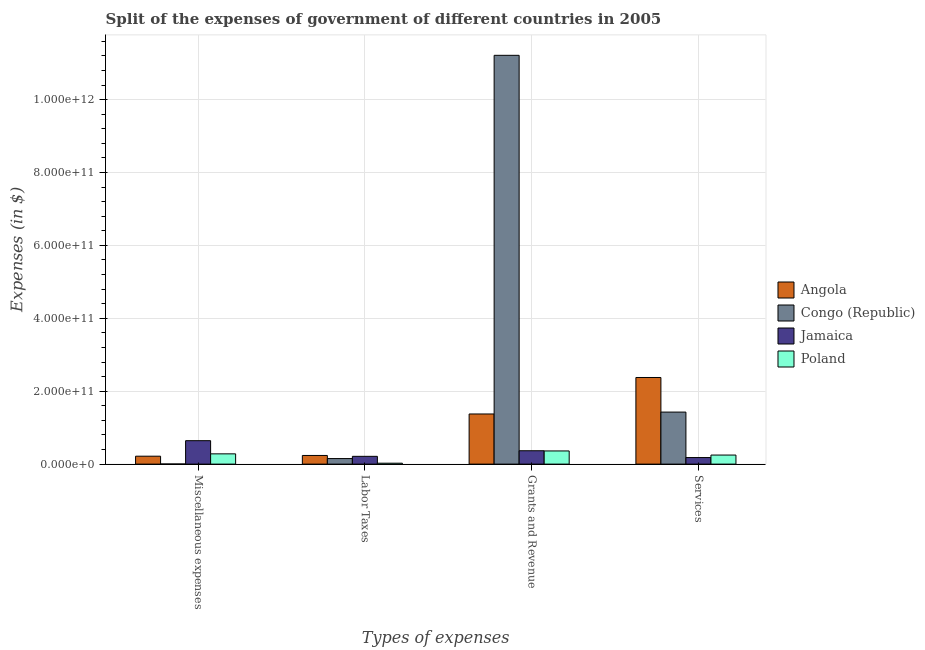Are the number of bars on each tick of the X-axis equal?
Give a very brief answer. Yes. How many bars are there on the 2nd tick from the left?
Your response must be concise. 4. What is the label of the 3rd group of bars from the left?
Provide a succinct answer. Grants and Revenue. What is the amount spent on miscellaneous expenses in Jamaica?
Offer a terse response. 6.43e+1. Across all countries, what is the maximum amount spent on services?
Provide a succinct answer. 2.38e+11. Across all countries, what is the minimum amount spent on grants and revenue?
Give a very brief answer. 3.61e+1. In which country was the amount spent on grants and revenue maximum?
Offer a terse response. Congo (Republic). In which country was the amount spent on miscellaneous expenses minimum?
Your answer should be compact. Congo (Republic). What is the total amount spent on services in the graph?
Make the answer very short. 4.23e+11. What is the difference between the amount spent on grants and revenue in Angola and that in Poland?
Make the answer very short. 1.01e+11. What is the difference between the amount spent on labor taxes in Angola and the amount spent on grants and revenue in Congo (Republic)?
Keep it short and to the point. -1.10e+12. What is the average amount spent on services per country?
Make the answer very short. 1.06e+11. What is the difference between the amount spent on labor taxes and amount spent on grants and revenue in Jamaica?
Provide a short and direct response. -1.53e+1. What is the ratio of the amount spent on services in Jamaica to that in Poland?
Offer a terse response. 0.72. Is the difference between the amount spent on services in Poland and Congo (Republic) greater than the difference between the amount spent on miscellaneous expenses in Poland and Congo (Republic)?
Keep it short and to the point. No. What is the difference between the highest and the second highest amount spent on services?
Provide a succinct answer. 9.49e+1. What is the difference between the highest and the lowest amount spent on labor taxes?
Your answer should be compact. 2.12e+1. Are all the bars in the graph horizontal?
Your response must be concise. No. What is the difference between two consecutive major ticks on the Y-axis?
Offer a very short reply. 2.00e+11. Does the graph contain any zero values?
Keep it short and to the point. No. Does the graph contain grids?
Give a very brief answer. Yes. How many legend labels are there?
Give a very brief answer. 4. What is the title of the graph?
Keep it short and to the point. Split of the expenses of government of different countries in 2005. Does "Cambodia" appear as one of the legend labels in the graph?
Provide a short and direct response. No. What is the label or title of the X-axis?
Give a very brief answer. Types of expenses. What is the label or title of the Y-axis?
Provide a short and direct response. Expenses (in $). What is the Expenses (in $) in Angola in Miscellaneous expenses?
Provide a short and direct response. 2.17e+1. What is the Expenses (in $) of Congo (Republic) in Miscellaneous expenses?
Your answer should be very brief. 3.32e+08. What is the Expenses (in $) in Jamaica in Miscellaneous expenses?
Your response must be concise. 6.43e+1. What is the Expenses (in $) of Poland in Miscellaneous expenses?
Ensure brevity in your answer.  2.82e+1. What is the Expenses (in $) of Angola in Labor Taxes?
Provide a succinct answer. 2.37e+1. What is the Expenses (in $) of Congo (Republic) in Labor Taxes?
Offer a very short reply. 1.52e+1. What is the Expenses (in $) in Jamaica in Labor Taxes?
Offer a terse response. 2.14e+1. What is the Expenses (in $) in Poland in Labor Taxes?
Make the answer very short. 2.50e+09. What is the Expenses (in $) of Angola in Grants and Revenue?
Your answer should be very brief. 1.38e+11. What is the Expenses (in $) in Congo (Republic) in Grants and Revenue?
Provide a succinct answer. 1.12e+12. What is the Expenses (in $) in Jamaica in Grants and Revenue?
Your answer should be compact. 3.67e+1. What is the Expenses (in $) of Poland in Grants and Revenue?
Your response must be concise. 3.61e+1. What is the Expenses (in $) in Angola in Services?
Ensure brevity in your answer.  2.38e+11. What is the Expenses (in $) of Congo (Republic) in Services?
Ensure brevity in your answer.  1.43e+11. What is the Expenses (in $) of Jamaica in Services?
Your response must be concise. 1.80e+1. What is the Expenses (in $) of Poland in Services?
Your answer should be compact. 2.49e+1. Across all Types of expenses, what is the maximum Expenses (in $) in Angola?
Your answer should be very brief. 2.38e+11. Across all Types of expenses, what is the maximum Expenses (in $) in Congo (Republic)?
Give a very brief answer. 1.12e+12. Across all Types of expenses, what is the maximum Expenses (in $) in Jamaica?
Keep it short and to the point. 6.43e+1. Across all Types of expenses, what is the maximum Expenses (in $) of Poland?
Make the answer very short. 3.61e+1. Across all Types of expenses, what is the minimum Expenses (in $) of Angola?
Keep it short and to the point. 2.17e+1. Across all Types of expenses, what is the minimum Expenses (in $) of Congo (Republic)?
Provide a short and direct response. 3.32e+08. Across all Types of expenses, what is the minimum Expenses (in $) of Jamaica?
Make the answer very short. 1.80e+1. Across all Types of expenses, what is the minimum Expenses (in $) of Poland?
Give a very brief answer. 2.50e+09. What is the total Expenses (in $) of Angola in the graph?
Provide a short and direct response. 4.21e+11. What is the total Expenses (in $) in Congo (Republic) in the graph?
Offer a terse response. 1.28e+12. What is the total Expenses (in $) in Jamaica in the graph?
Make the answer very short. 1.40e+11. What is the total Expenses (in $) in Poland in the graph?
Make the answer very short. 9.17e+1. What is the difference between the Expenses (in $) in Angola in Miscellaneous expenses and that in Labor Taxes?
Your answer should be very brief. -1.98e+09. What is the difference between the Expenses (in $) in Congo (Republic) in Miscellaneous expenses and that in Labor Taxes?
Ensure brevity in your answer.  -1.49e+1. What is the difference between the Expenses (in $) of Jamaica in Miscellaneous expenses and that in Labor Taxes?
Ensure brevity in your answer.  4.30e+1. What is the difference between the Expenses (in $) in Poland in Miscellaneous expenses and that in Labor Taxes?
Offer a terse response. 2.57e+1. What is the difference between the Expenses (in $) in Angola in Miscellaneous expenses and that in Grants and Revenue?
Your answer should be very brief. -1.16e+11. What is the difference between the Expenses (in $) of Congo (Republic) in Miscellaneous expenses and that in Grants and Revenue?
Offer a very short reply. -1.12e+12. What is the difference between the Expenses (in $) of Jamaica in Miscellaneous expenses and that in Grants and Revenue?
Offer a terse response. 2.76e+1. What is the difference between the Expenses (in $) of Poland in Miscellaneous expenses and that in Grants and Revenue?
Your answer should be very brief. -7.94e+09. What is the difference between the Expenses (in $) of Angola in Miscellaneous expenses and that in Services?
Provide a short and direct response. -2.16e+11. What is the difference between the Expenses (in $) of Congo (Republic) in Miscellaneous expenses and that in Services?
Offer a very short reply. -1.42e+11. What is the difference between the Expenses (in $) in Jamaica in Miscellaneous expenses and that in Services?
Provide a short and direct response. 4.63e+1. What is the difference between the Expenses (in $) in Poland in Miscellaneous expenses and that in Services?
Ensure brevity in your answer.  3.32e+09. What is the difference between the Expenses (in $) in Angola in Labor Taxes and that in Grants and Revenue?
Offer a terse response. -1.14e+11. What is the difference between the Expenses (in $) in Congo (Republic) in Labor Taxes and that in Grants and Revenue?
Your answer should be compact. -1.11e+12. What is the difference between the Expenses (in $) of Jamaica in Labor Taxes and that in Grants and Revenue?
Ensure brevity in your answer.  -1.53e+1. What is the difference between the Expenses (in $) in Poland in Labor Taxes and that in Grants and Revenue?
Keep it short and to the point. -3.36e+1. What is the difference between the Expenses (in $) in Angola in Labor Taxes and that in Services?
Ensure brevity in your answer.  -2.14e+11. What is the difference between the Expenses (in $) of Congo (Republic) in Labor Taxes and that in Services?
Ensure brevity in your answer.  -1.28e+11. What is the difference between the Expenses (in $) in Jamaica in Labor Taxes and that in Services?
Keep it short and to the point. 3.35e+09. What is the difference between the Expenses (in $) in Poland in Labor Taxes and that in Services?
Your response must be concise. -2.24e+1. What is the difference between the Expenses (in $) in Angola in Grants and Revenue and that in Services?
Your answer should be compact. -1.00e+11. What is the difference between the Expenses (in $) in Congo (Republic) in Grants and Revenue and that in Services?
Keep it short and to the point. 9.79e+11. What is the difference between the Expenses (in $) of Jamaica in Grants and Revenue and that in Services?
Your answer should be compact. 1.87e+1. What is the difference between the Expenses (in $) in Poland in Grants and Revenue and that in Services?
Make the answer very short. 1.13e+1. What is the difference between the Expenses (in $) in Angola in Miscellaneous expenses and the Expenses (in $) in Congo (Republic) in Labor Taxes?
Make the answer very short. 6.53e+09. What is the difference between the Expenses (in $) of Angola in Miscellaneous expenses and the Expenses (in $) of Jamaica in Labor Taxes?
Your answer should be compact. 3.93e+08. What is the difference between the Expenses (in $) of Angola in Miscellaneous expenses and the Expenses (in $) of Poland in Labor Taxes?
Ensure brevity in your answer.  1.92e+1. What is the difference between the Expenses (in $) of Congo (Republic) in Miscellaneous expenses and the Expenses (in $) of Jamaica in Labor Taxes?
Make the answer very short. -2.10e+1. What is the difference between the Expenses (in $) in Congo (Republic) in Miscellaneous expenses and the Expenses (in $) in Poland in Labor Taxes?
Keep it short and to the point. -2.17e+09. What is the difference between the Expenses (in $) of Jamaica in Miscellaneous expenses and the Expenses (in $) of Poland in Labor Taxes?
Ensure brevity in your answer.  6.18e+1. What is the difference between the Expenses (in $) in Angola in Miscellaneous expenses and the Expenses (in $) in Congo (Republic) in Grants and Revenue?
Provide a succinct answer. -1.10e+12. What is the difference between the Expenses (in $) of Angola in Miscellaneous expenses and the Expenses (in $) of Jamaica in Grants and Revenue?
Provide a short and direct response. -1.49e+1. What is the difference between the Expenses (in $) of Angola in Miscellaneous expenses and the Expenses (in $) of Poland in Grants and Revenue?
Provide a succinct answer. -1.44e+1. What is the difference between the Expenses (in $) in Congo (Republic) in Miscellaneous expenses and the Expenses (in $) in Jamaica in Grants and Revenue?
Keep it short and to the point. -3.63e+1. What is the difference between the Expenses (in $) in Congo (Republic) in Miscellaneous expenses and the Expenses (in $) in Poland in Grants and Revenue?
Make the answer very short. -3.58e+1. What is the difference between the Expenses (in $) of Jamaica in Miscellaneous expenses and the Expenses (in $) of Poland in Grants and Revenue?
Your answer should be compact. 2.82e+1. What is the difference between the Expenses (in $) of Angola in Miscellaneous expenses and the Expenses (in $) of Congo (Republic) in Services?
Make the answer very short. -1.21e+11. What is the difference between the Expenses (in $) in Angola in Miscellaneous expenses and the Expenses (in $) in Jamaica in Services?
Make the answer very short. 3.74e+09. What is the difference between the Expenses (in $) in Angola in Miscellaneous expenses and the Expenses (in $) in Poland in Services?
Your answer should be very brief. -3.11e+09. What is the difference between the Expenses (in $) of Congo (Republic) in Miscellaneous expenses and the Expenses (in $) of Jamaica in Services?
Provide a short and direct response. -1.77e+1. What is the difference between the Expenses (in $) of Congo (Republic) in Miscellaneous expenses and the Expenses (in $) of Poland in Services?
Provide a short and direct response. -2.45e+1. What is the difference between the Expenses (in $) of Jamaica in Miscellaneous expenses and the Expenses (in $) of Poland in Services?
Ensure brevity in your answer.  3.95e+1. What is the difference between the Expenses (in $) in Angola in Labor Taxes and the Expenses (in $) in Congo (Republic) in Grants and Revenue?
Your answer should be very brief. -1.10e+12. What is the difference between the Expenses (in $) of Angola in Labor Taxes and the Expenses (in $) of Jamaica in Grants and Revenue?
Your answer should be very brief. -1.30e+1. What is the difference between the Expenses (in $) in Angola in Labor Taxes and the Expenses (in $) in Poland in Grants and Revenue?
Your answer should be very brief. -1.24e+1. What is the difference between the Expenses (in $) in Congo (Republic) in Labor Taxes and the Expenses (in $) in Jamaica in Grants and Revenue?
Offer a very short reply. -2.15e+1. What is the difference between the Expenses (in $) of Congo (Republic) in Labor Taxes and the Expenses (in $) of Poland in Grants and Revenue?
Offer a very short reply. -2.09e+1. What is the difference between the Expenses (in $) in Jamaica in Labor Taxes and the Expenses (in $) in Poland in Grants and Revenue?
Your answer should be very brief. -1.48e+1. What is the difference between the Expenses (in $) in Angola in Labor Taxes and the Expenses (in $) in Congo (Republic) in Services?
Your answer should be very brief. -1.19e+11. What is the difference between the Expenses (in $) in Angola in Labor Taxes and the Expenses (in $) in Jamaica in Services?
Your answer should be compact. 5.72e+09. What is the difference between the Expenses (in $) of Angola in Labor Taxes and the Expenses (in $) of Poland in Services?
Offer a very short reply. -1.13e+09. What is the difference between the Expenses (in $) of Congo (Republic) in Labor Taxes and the Expenses (in $) of Jamaica in Services?
Your answer should be very brief. -2.79e+09. What is the difference between the Expenses (in $) in Congo (Republic) in Labor Taxes and the Expenses (in $) in Poland in Services?
Your answer should be very brief. -9.64e+09. What is the difference between the Expenses (in $) in Jamaica in Labor Taxes and the Expenses (in $) in Poland in Services?
Offer a very short reply. -3.51e+09. What is the difference between the Expenses (in $) in Angola in Grants and Revenue and the Expenses (in $) in Congo (Republic) in Services?
Your response must be concise. -5.18e+09. What is the difference between the Expenses (in $) in Angola in Grants and Revenue and the Expenses (in $) in Jamaica in Services?
Your response must be concise. 1.20e+11. What is the difference between the Expenses (in $) of Angola in Grants and Revenue and the Expenses (in $) of Poland in Services?
Make the answer very short. 1.13e+11. What is the difference between the Expenses (in $) of Congo (Republic) in Grants and Revenue and the Expenses (in $) of Jamaica in Services?
Offer a very short reply. 1.10e+12. What is the difference between the Expenses (in $) in Congo (Republic) in Grants and Revenue and the Expenses (in $) in Poland in Services?
Your answer should be compact. 1.10e+12. What is the difference between the Expenses (in $) in Jamaica in Grants and Revenue and the Expenses (in $) in Poland in Services?
Your answer should be compact. 1.18e+1. What is the average Expenses (in $) in Angola per Types of expenses?
Offer a terse response. 1.05e+11. What is the average Expenses (in $) in Congo (Republic) per Types of expenses?
Your answer should be compact. 3.20e+11. What is the average Expenses (in $) of Jamaica per Types of expenses?
Ensure brevity in your answer.  3.51e+1. What is the average Expenses (in $) of Poland per Types of expenses?
Offer a very short reply. 2.29e+1. What is the difference between the Expenses (in $) of Angola and Expenses (in $) of Congo (Republic) in Miscellaneous expenses?
Your answer should be compact. 2.14e+1. What is the difference between the Expenses (in $) of Angola and Expenses (in $) of Jamaica in Miscellaneous expenses?
Your answer should be compact. -4.26e+1. What is the difference between the Expenses (in $) in Angola and Expenses (in $) in Poland in Miscellaneous expenses?
Keep it short and to the point. -6.43e+09. What is the difference between the Expenses (in $) in Congo (Republic) and Expenses (in $) in Jamaica in Miscellaneous expenses?
Make the answer very short. -6.40e+1. What is the difference between the Expenses (in $) in Congo (Republic) and Expenses (in $) in Poland in Miscellaneous expenses?
Provide a succinct answer. -2.78e+1. What is the difference between the Expenses (in $) of Jamaica and Expenses (in $) of Poland in Miscellaneous expenses?
Your answer should be compact. 3.61e+1. What is the difference between the Expenses (in $) of Angola and Expenses (in $) of Congo (Republic) in Labor Taxes?
Give a very brief answer. 8.51e+09. What is the difference between the Expenses (in $) of Angola and Expenses (in $) of Jamaica in Labor Taxes?
Offer a very short reply. 2.37e+09. What is the difference between the Expenses (in $) of Angola and Expenses (in $) of Poland in Labor Taxes?
Keep it short and to the point. 2.12e+1. What is the difference between the Expenses (in $) of Congo (Republic) and Expenses (in $) of Jamaica in Labor Taxes?
Offer a terse response. -6.14e+09. What is the difference between the Expenses (in $) of Congo (Republic) and Expenses (in $) of Poland in Labor Taxes?
Ensure brevity in your answer.  1.27e+1. What is the difference between the Expenses (in $) in Jamaica and Expenses (in $) in Poland in Labor Taxes?
Keep it short and to the point. 1.88e+1. What is the difference between the Expenses (in $) of Angola and Expenses (in $) of Congo (Republic) in Grants and Revenue?
Your response must be concise. -9.84e+11. What is the difference between the Expenses (in $) in Angola and Expenses (in $) in Jamaica in Grants and Revenue?
Your answer should be very brief. 1.01e+11. What is the difference between the Expenses (in $) of Angola and Expenses (in $) of Poland in Grants and Revenue?
Keep it short and to the point. 1.01e+11. What is the difference between the Expenses (in $) in Congo (Republic) and Expenses (in $) in Jamaica in Grants and Revenue?
Provide a short and direct response. 1.08e+12. What is the difference between the Expenses (in $) in Congo (Republic) and Expenses (in $) in Poland in Grants and Revenue?
Provide a short and direct response. 1.09e+12. What is the difference between the Expenses (in $) of Jamaica and Expenses (in $) of Poland in Grants and Revenue?
Provide a short and direct response. 5.64e+08. What is the difference between the Expenses (in $) of Angola and Expenses (in $) of Congo (Republic) in Services?
Your answer should be compact. 9.49e+1. What is the difference between the Expenses (in $) in Angola and Expenses (in $) in Jamaica in Services?
Ensure brevity in your answer.  2.20e+11. What is the difference between the Expenses (in $) in Angola and Expenses (in $) in Poland in Services?
Your response must be concise. 2.13e+11. What is the difference between the Expenses (in $) in Congo (Republic) and Expenses (in $) in Jamaica in Services?
Offer a terse response. 1.25e+11. What is the difference between the Expenses (in $) of Congo (Republic) and Expenses (in $) of Poland in Services?
Provide a succinct answer. 1.18e+11. What is the difference between the Expenses (in $) in Jamaica and Expenses (in $) in Poland in Services?
Keep it short and to the point. -6.86e+09. What is the ratio of the Expenses (in $) of Angola in Miscellaneous expenses to that in Labor Taxes?
Give a very brief answer. 0.92. What is the ratio of the Expenses (in $) of Congo (Republic) in Miscellaneous expenses to that in Labor Taxes?
Ensure brevity in your answer.  0.02. What is the ratio of the Expenses (in $) of Jamaica in Miscellaneous expenses to that in Labor Taxes?
Provide a succinct answer. 3.01. What is the ratio of the Expenses (in $) in Poland in Miscellaneous expenses to that in Labor Taxes?
Provide a succinct answer. 11.25. What is the ratio of the Expenses (in $) of Angola in Miscellaneous expenses to that in Grants and Revenue?
Ensure brevity in your answer.  0.16. What is the ratio of the Expenses (in $) of Jamaica in Miscellaneous expenses to that in Grants and Revenue?
Your answer should be compact. 1.75. What is the ratio of the Expenses (in $) in Poland in Miscellaneous expenses to that in Grants and Revenue?
Provide a succinct answer. 0.78. What is the ratio of the Expenses (in $) in Angola in Miscellaneous expenses to that in Services?
Provide a short and direct response. 0.09. What is the ratio of the Expenses (in $) in Congo (Republic) in Miscellaneous expenses to that in Services?
Offer a very short reply. 0. What is the ratio of the Expenses (in $) of Jamaica in Miscellaneous expenses to that in Services?
Ensure brevity in your answer.  3.57. What is the ratio of the Expenses (in $) in Poland in Miscellaneous expenses to that in Services?
Offer a very short reply. 1.13. What is the ratio of the Expenses (in $) in Angola in Labor Taxes to that in Grants and Revenue?
Your answer should be compact. 0.17. What is the ratio of the Expenses (in $) of Congo (Republic) in Labor Taxes to that in Grants and Revenue?
Make the answer very short. 0.01. What is the ratio of the Expenses (in $) of Jamaica in Labor Taxes to that in Grants and Revenue?
Provide a succinct answer. 0.58. What is the ratio of the Expenses (in $) in Poland in Labor Taxes to that in Grants and Revenue?
Make the answer very short. 0.07. What is the ratio of the Expenses (in $) of Angola in Labor Taxes to that in Services?
Ensure brevity in your answer.  0.1. What is the ratio of the Expenses (in $) in Congo (Republic) in Labor Taxes to that in Services?
Your response must be concise. 0.11. What is the ratio of the Expenses (in $) of Jamaica in Labor Taxes to that in Services?
Keep it short and to the point. 1.19. What is the ratio of the Expenses (in $) of Poland in Labor Taxes to that in Services?
Keep it short and to the point. 0.1. What is the ratio of the Expenses (in $) of Angola in Grants and Revenue to that in Services?
Provide a succinct answer. 0.58. What is the ratio of the Expenses (in $) of Congo (Republic) in Grants and Revenue to that in Services?
Ensure brevity in your answer.  7.86. What is the ratio of the Expenses (in $) of Jamaica in Grants and Revenue to that in Services?
Make the answer very short. 2.04. What is the ratio of the Expenses (in $) in Poland in Grants and Revenue to that in Services?
Make the answer very short. 1.45. What is the difference between the highest and the second highest Expenses (in $) of Angola?
Your answer should be very brief. 1.00e+11. What is the difference between the highest and the second highest Expenses (in $) of Congo (Republic)?
Offer a terse response. 9.79e+11. What is the difference between the highest and the second highest Expenses (in $) of Jamaica?
Your answer should be compact. 2.76e+1. What is the difference between the highest and the second highest Expenses (in $) in Poland?
Ensure brevity in your answer.  7.94e+09. What is the difference between the highest and the lowest Expenses (in $) of Angola?
Give a very brief answer. 2.16e+11. What is the difference between the highest and the lowest Expenses (in $) of Congo (Republic)?
Your answer should be very brief. 1.12e+12. What is the difference between the highest and the lowest Expenses (in $) in Jamaica?
Make the answer very short. 4.63e+1. What is the difference between the highest and the lowest Expenses (in $) in Poland?
Offer a very short reply. 3.36e+1. 